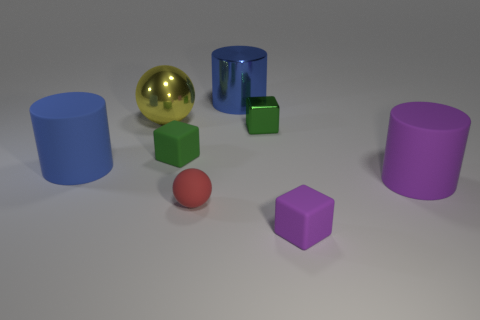Add 1 balls. How many objects exist? 9 Subtract all cubes. How many objects are left? 5 Subtract all yellow shiny objects. Subtract all small blue shiny blocks. How many objects are left? 7 Add 4 big purple matte cylinders. How many big purple matte cylinders are left? 5 Add 8 purple blocks. How many purple blocks exist? 9 Subtract 0 cyan cylinders. How many objects are left? 8 